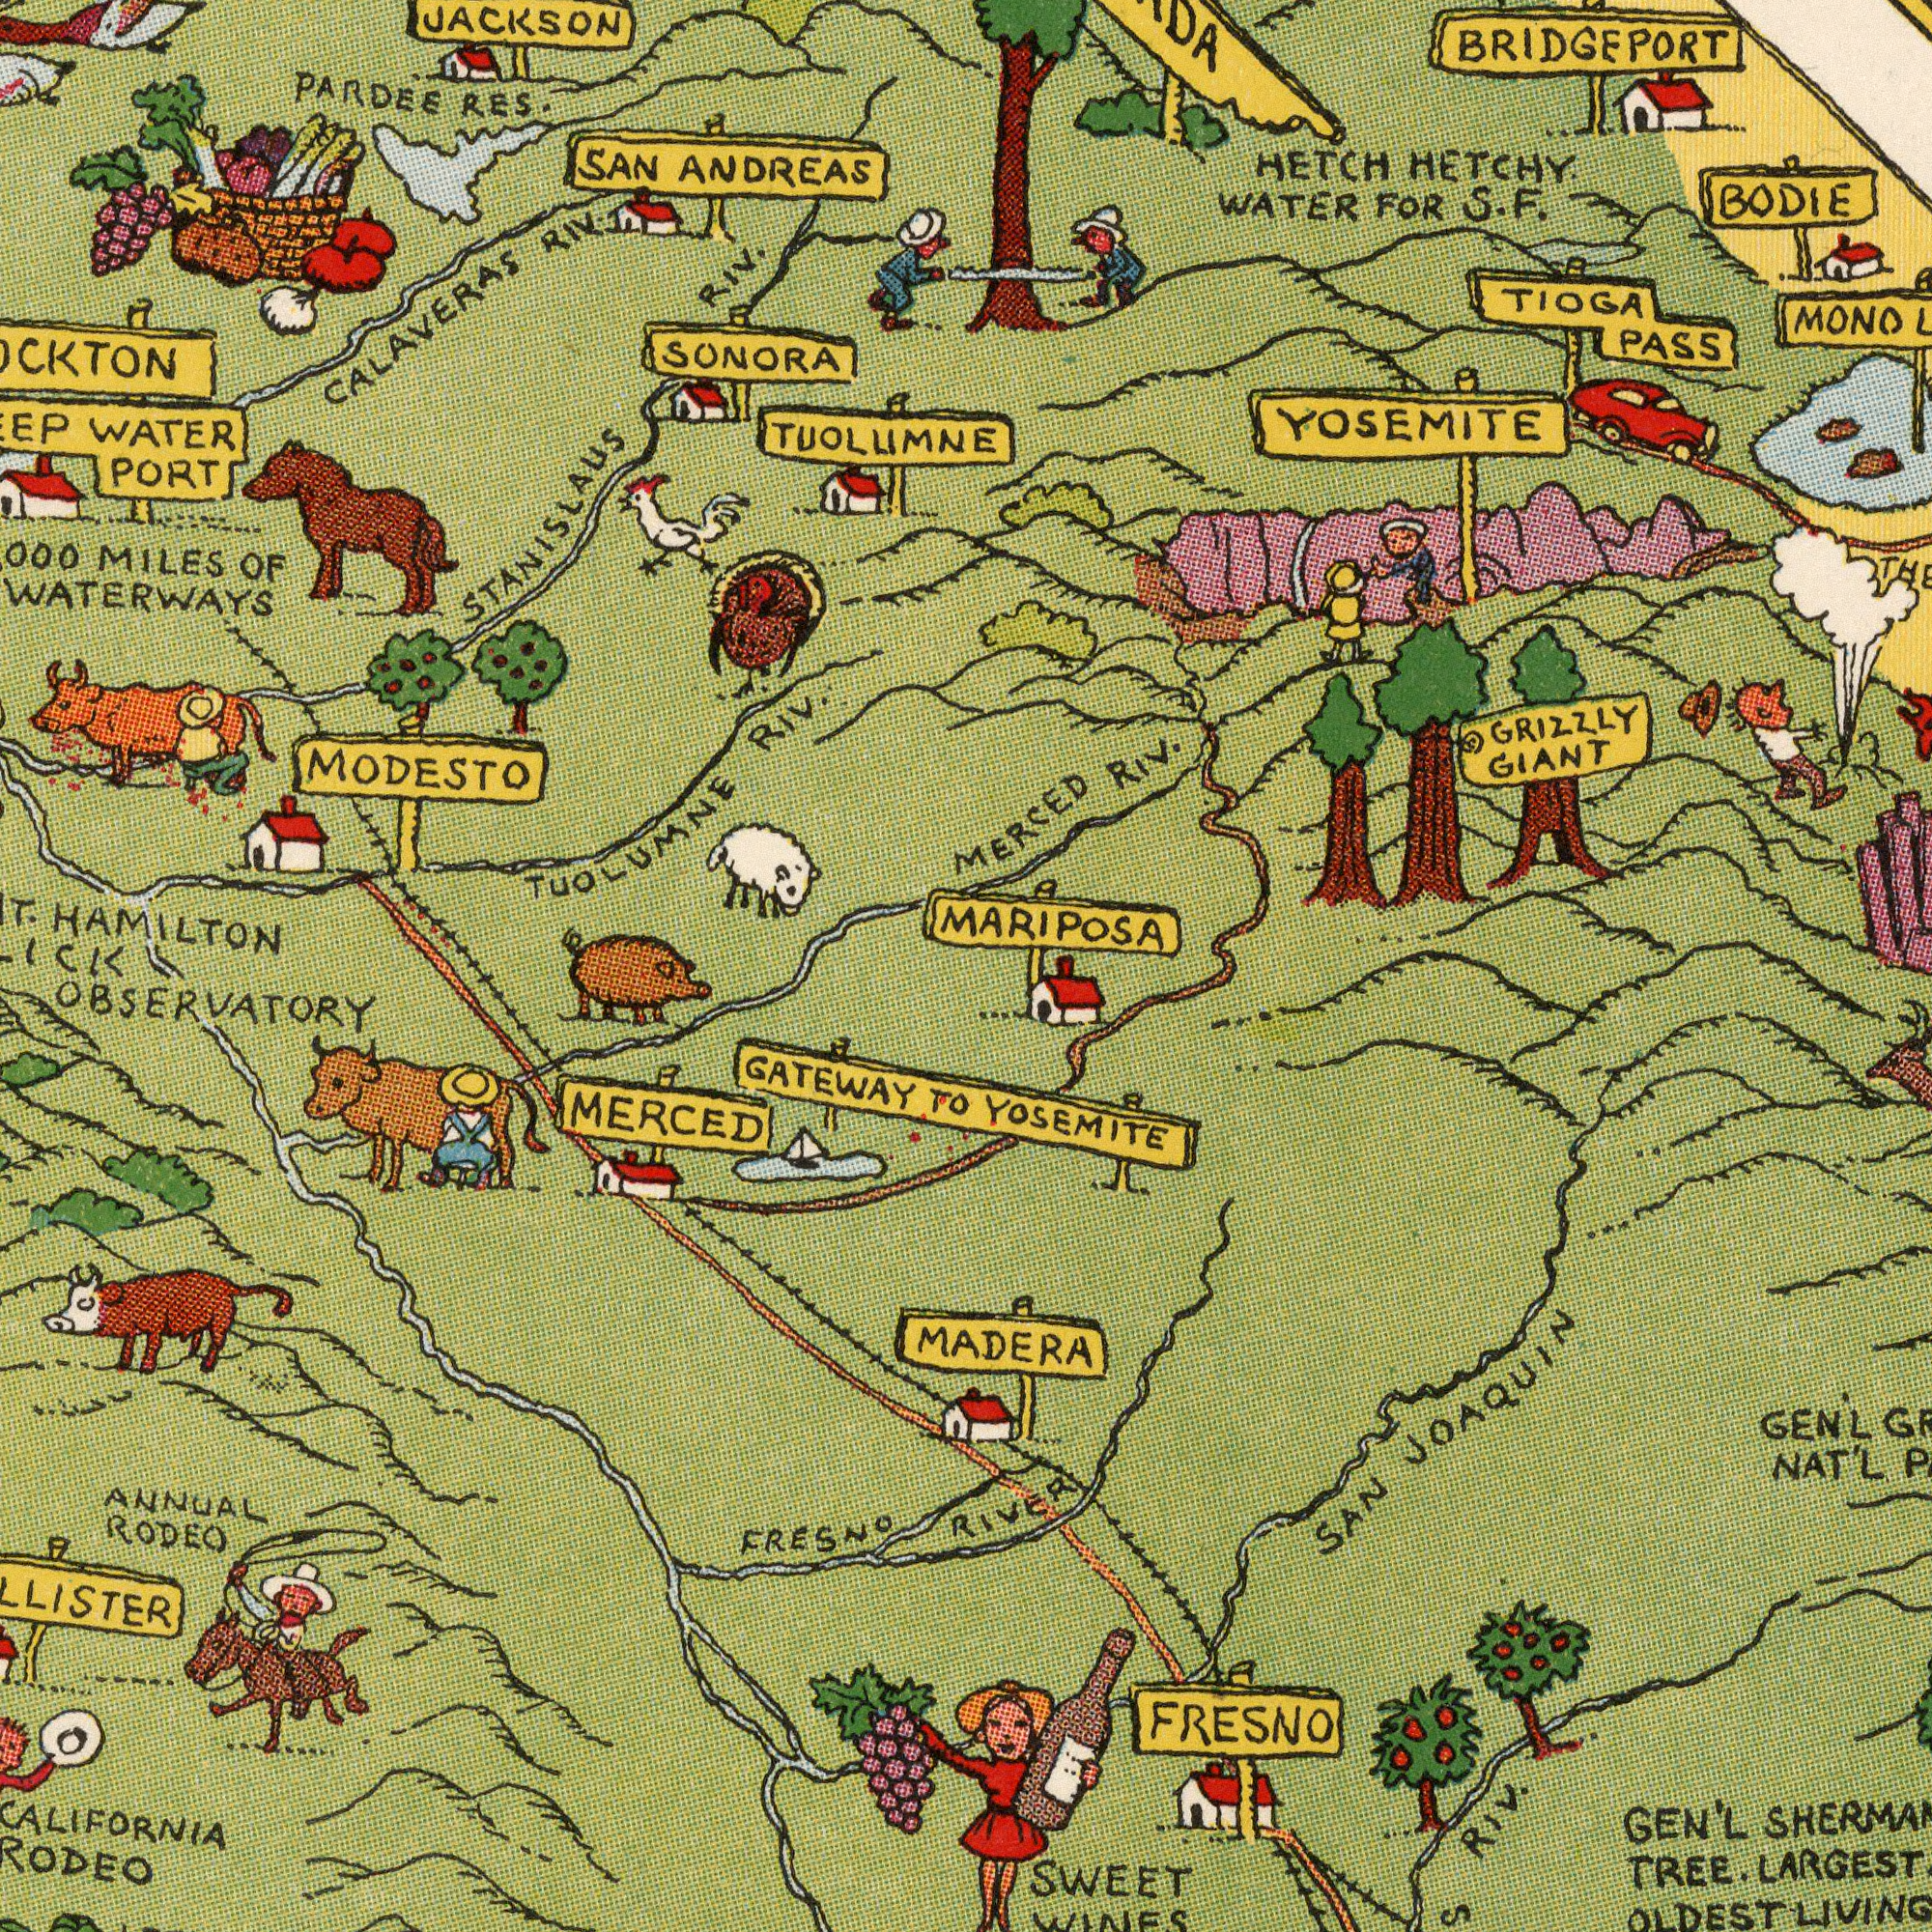What text is shown in the top-left quadrant? SAN ANDREAS TUOLLIMNE PARDEE RES. SONORA JACKSON HAMILTON WATER PORT MILES OF WATERWAYS CALAVERAS RIV. TUOLUMNE RIV. STANISLAUS RIV. MODESTO What text is visible in the lower-left corner? OBSERVATORY CALIFORNIA RODEO GATEWAY To FRESNO MERCED ANNUAL RODEO What text can you see in the top-right section? HETCH HETCHY. WATER FOR S. F. MONO MERCED Riv. BODIE GRIZZLY GIANT TIOGA PASS YOSEMITE BRIDGEPORT MARIPOSA What text appears in the bottom-right area of the image? YOSEMITE RIVER SWEET WINES SAN JOAQUIN GEN'L TREE. LARGEST OLDEST MADERA Riv. FRESNO GEN'L NAT'L 